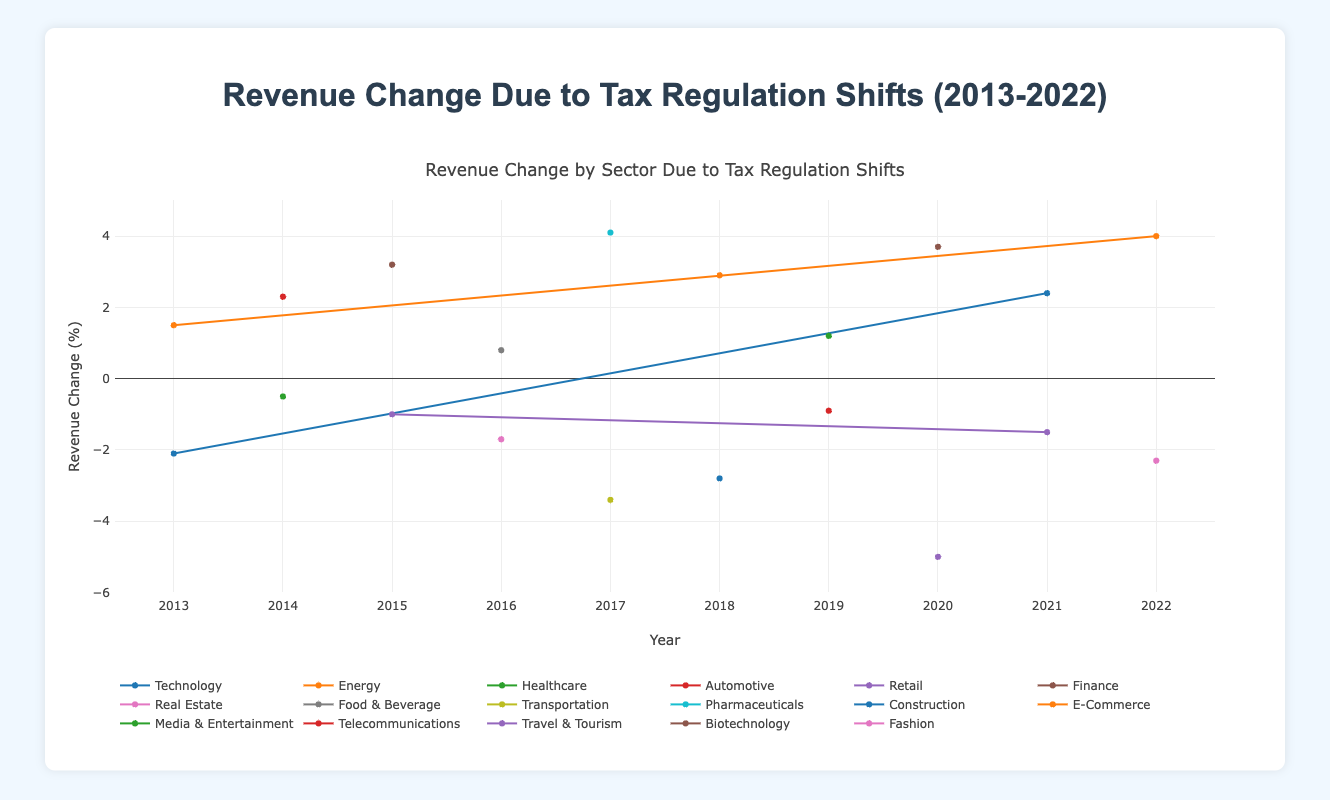Which sector experienced the largest positive revenue change due to tax regulation in 2022? Hover over the plots to see the data points for 2022. The "Renewable Energy Corp." in the Energy sector had a revenue change of 4.0%, which is the highest positive change in 2022.
Answer: Energy How did the 2020 pandemic-related tax regulations affect the Technology sector's revenue change? Compare the revenue change for Technology companies in 2020. "Cyber Security Co." in the Technology sector experienced a revenue increase of 2.4% due to "Cybersecurity Tax Incentives".
Answer: Revenue increased by 2.4% What is the average revenue change for the Retail sector from 2015 to 2021? Find the Retail data points for 2015 and 2021. In 2015, "Retail Ventures" had -1.0%, and in 2021, "Supermarket Chain" had -1.5%. The average is (-1.0 + (-1.5)) / 2 = -1.25%.
Answer: -1.25% Which company had the highest negative revenue change in 2020, and what caused it? Look for the largest negative drop in 2020. "Travel Adventures" in the Travel & Tourism sector had the largest negative revenue change at -5.0%, caused by the "Pandemic Emergency Tax".
Answer: Travel Adventures due to Pandemic Emergency Tax How did the revenue change for companies in the Energy sector compare between 2013 and 2022? Compare the 2013 and 2022 revenue changes for Energy sector companies. In 2013, "Green Energy Ltd." experienced a 1.5% increase due to the "Carbon Tax Credit". In 2022, "Renewable Energy Corp." saw a 4.0% increase due to the "Renewable Energy Subsidy".
Answer: Increased from 1.5% to 4.0% What was the cumulative revenue change for the Pharmaceuticals sector in 2017? Identify the Pharmaceuticals data for 2017. "Pharma Giants" had a revenue change of 4.1%. Since it is the only data point, the cumulative revenue change is 4.1%.
Answer: 4.1% Did any sector experience a positive revenue change every year? Examine each sector's data points year by year. No sector experienced a positive revenue change every year continuously.
Answer: No What is the difference in revenue change between "E-Commerce Titans" in 2018 and "Luxury Apparel" in 2022? Determine the values for both companies. "E-Commerce Titans" had a 2.9% increase in 2018, and "Luxury Apparel" had a -2.3% change in 2022. The difference is 2.9% - (-2.3%) = 5.2%.
Answer: 5.2% Which company experienced the most significant change in revenue within a single year, and what was the tax regulation behind it? Find the largest absolute change. "Travel Adventures" in 2020 had the most significant drop of -5.0%, due to the "Pandemic Emergency Tax".
Answer: Travel Adventures due to Pandemic Emergency Tax How did the tax regulation on R&D credits affect multiple sectors over the years represented? Identify companies benefiting from R&D credits and compare changes. "Pharma Giants" in 2017 experienced a large increase (4.1%) and "Biotech Innovations" in 2020 also saw a substantial rise (3.7%) due to R&D credits.
Answer: Significant positive revenue changes 